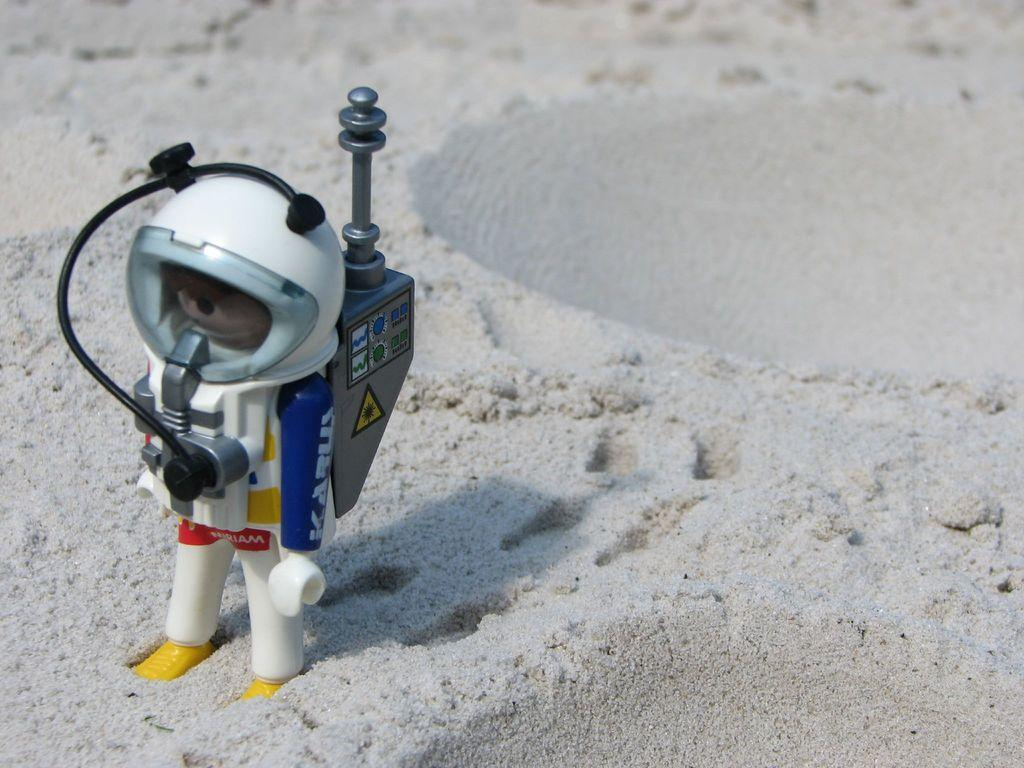What is the main subject of the image? There is a depiction of an astronaut in the image. What can be seen in the background of the image? There is sand visible in the background of the image. What type of corn is being harvested in the image? There is no corn present in the image; it features a depiction of an astronaut and sand in the background. What language is the astronaut speaking in the image? The image does not provide any information about the astronaut speaking or any language being spoken. 